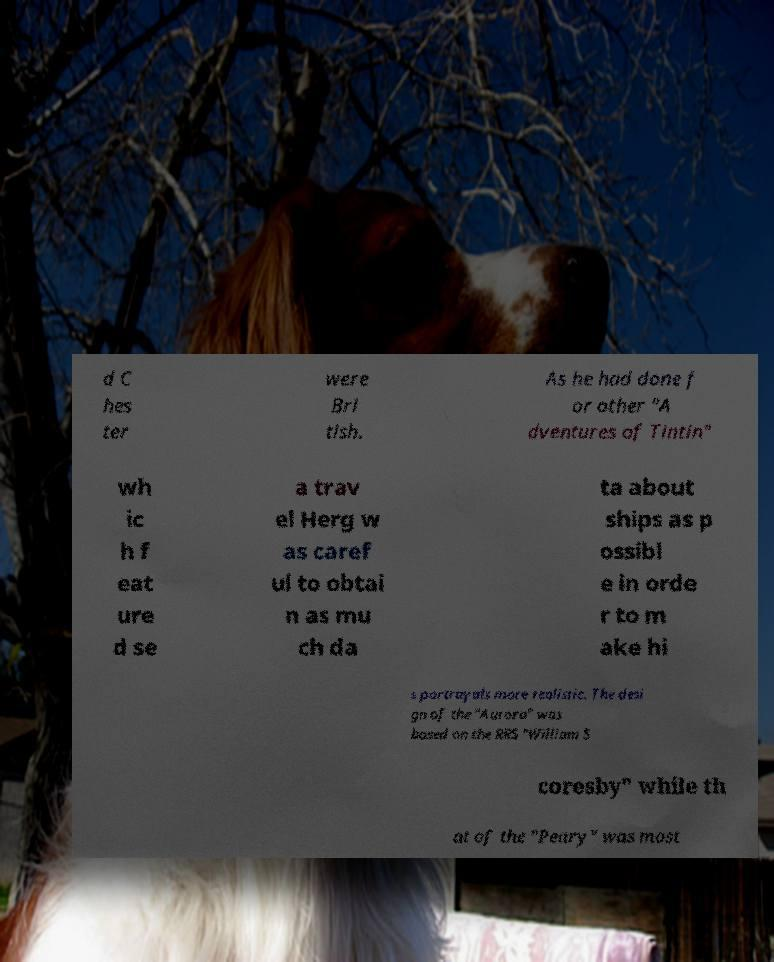There's text embedded in this image that I need extracted. Can you transcribe it verbatim? d C hes ter were Bri tish. As he had done f or other "A dventures of Tintin" wh ic h f eat ure d se a trav el Herg w as caref ul to obtai n as mu ch da ta about ships as p ossibl e in orde r to m ake hi s portrayals more realistic. The desi gn of the "Aurora" was based on the RRS "William S coresby" while th at of the "Peary" was most 